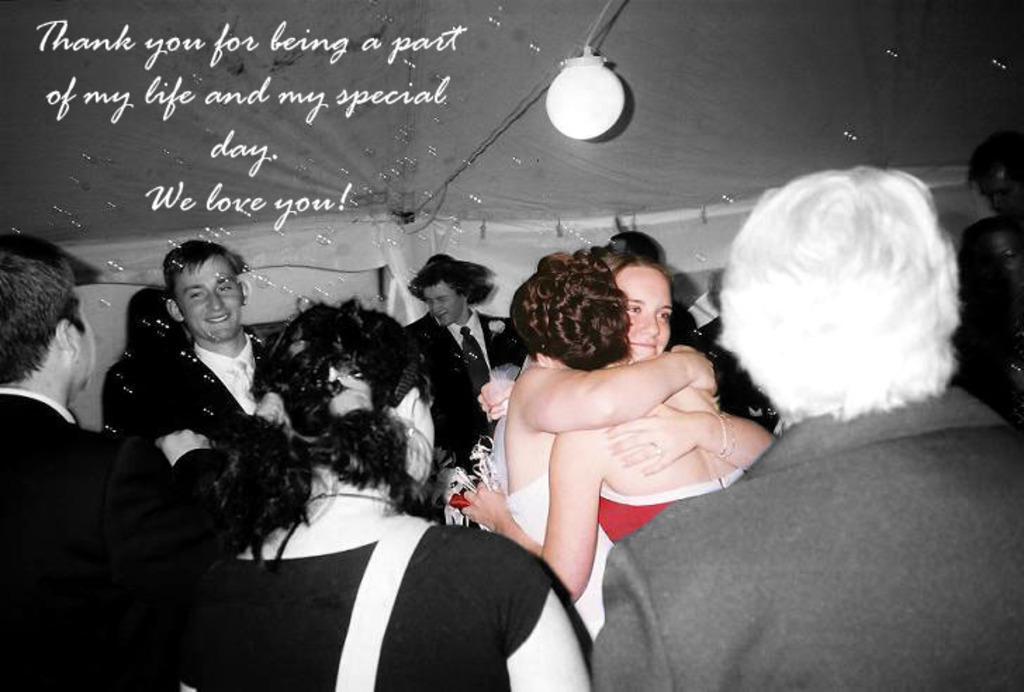Please provide a concise description of this image. In the image we can see there are many people around, they are wearing clothes, this is a watermark and a light. These are foam balloons. 